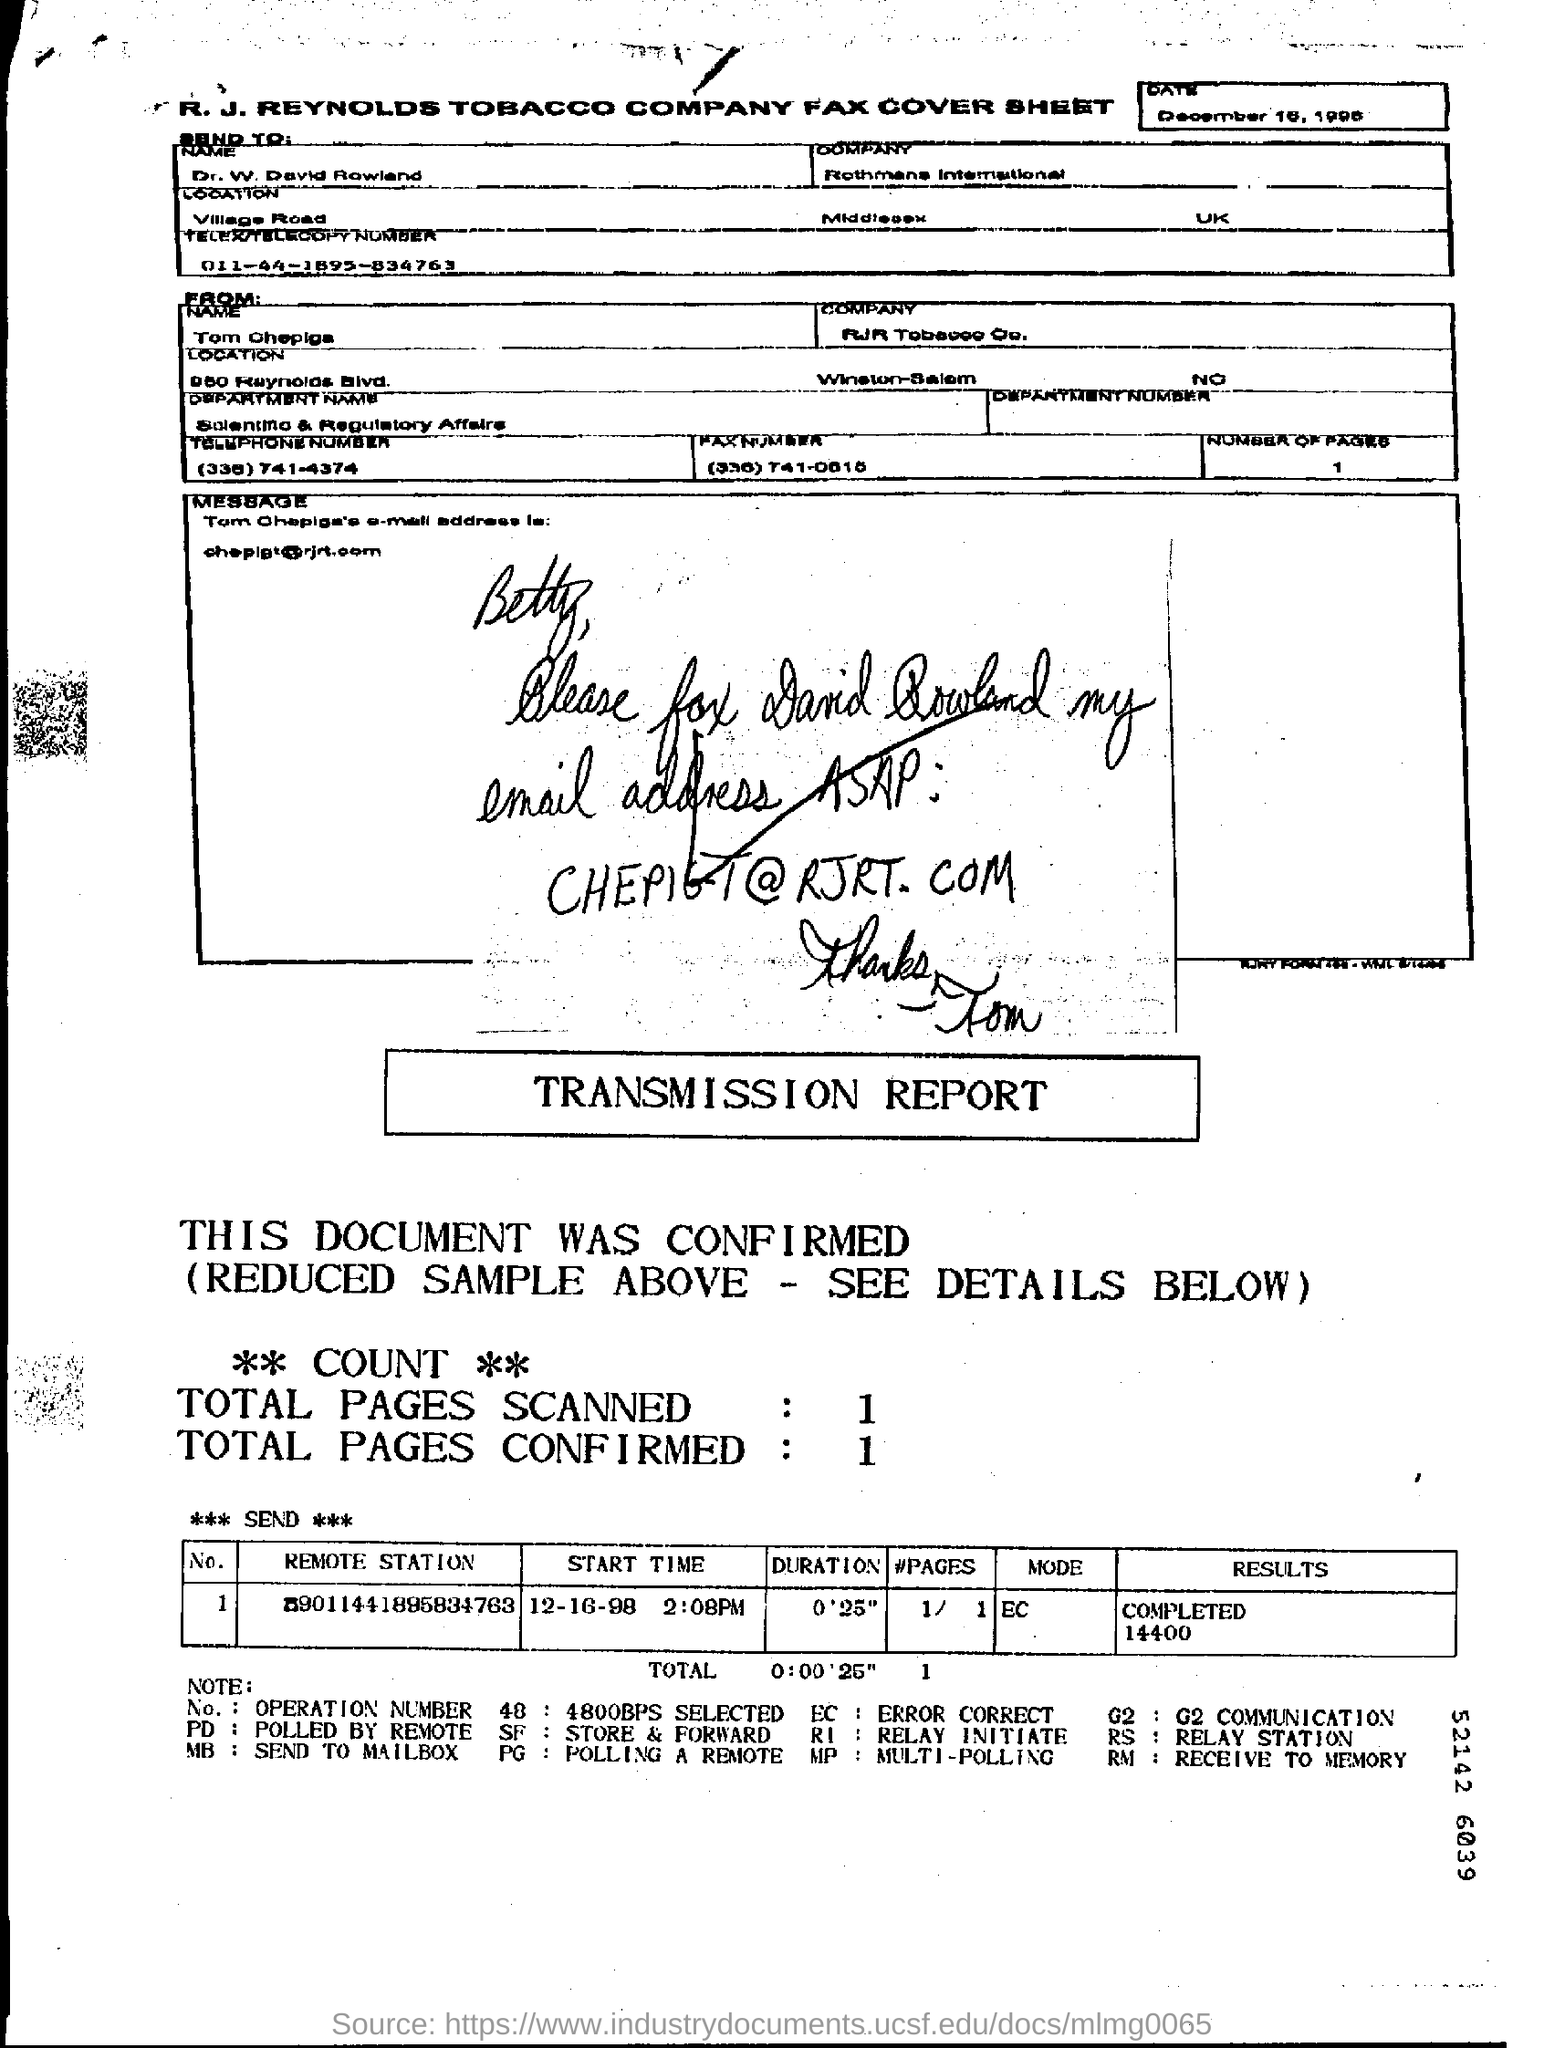What's the name of the company on the fax cover sheet? The company's name on the fax cover sheet is 'R. J. Reynolds Tobacco Company'. To whom was the fax addressed? The fax was addressed to a person named Betty, as seen in the handwritten note requesting to send the email address ASAP. 